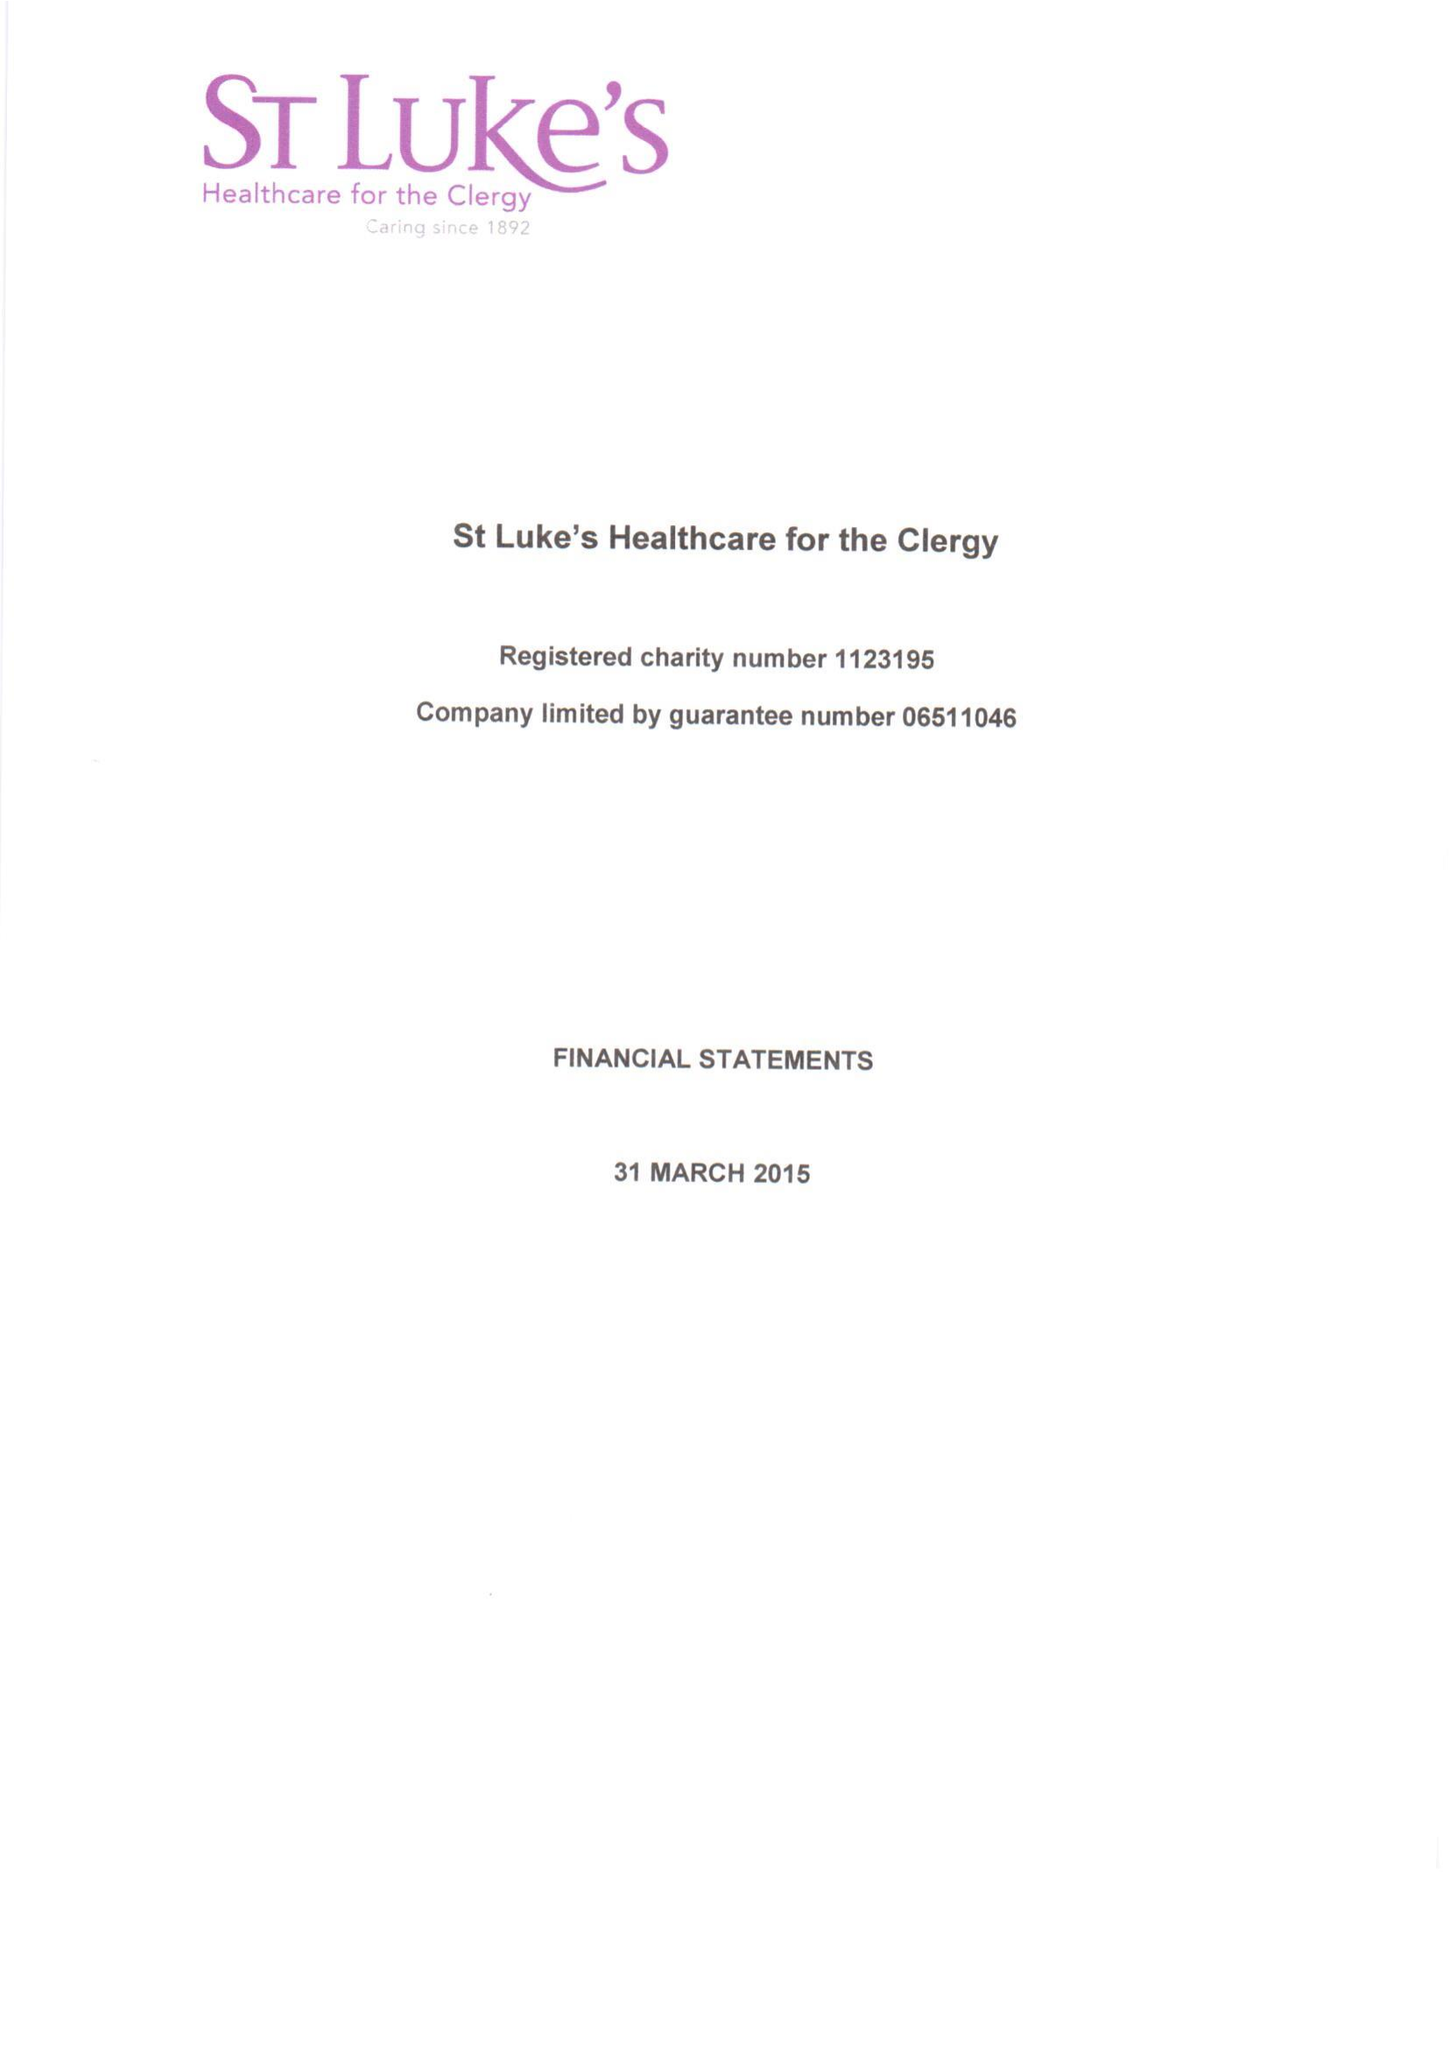What is the value for the address__street_line?
Answer the question using a single word or phrase. 27 GREAT SMITH STREET 